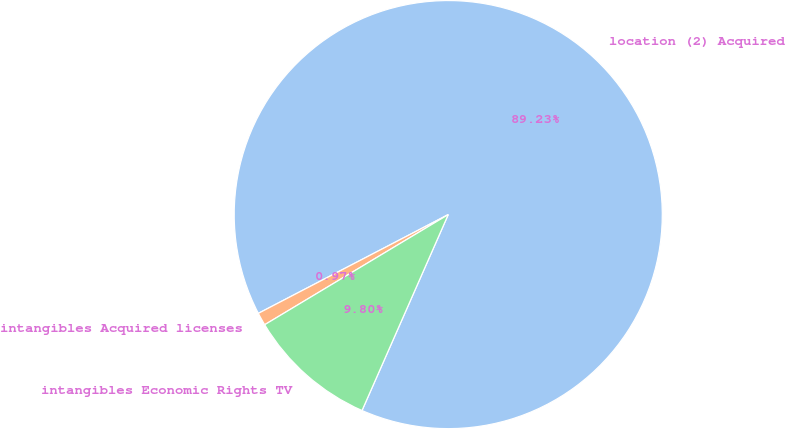<chart> <loc_0><loc_0><loc_500><loc_500><pie_chart><fcel>location (2) Acquired<fcel>intangibles Acquired licenses<fcel>intangibles Economic Rights TV<nl><fcel>89.23%<fcel>0.97%<fcel>9.8%<nl></chart> 